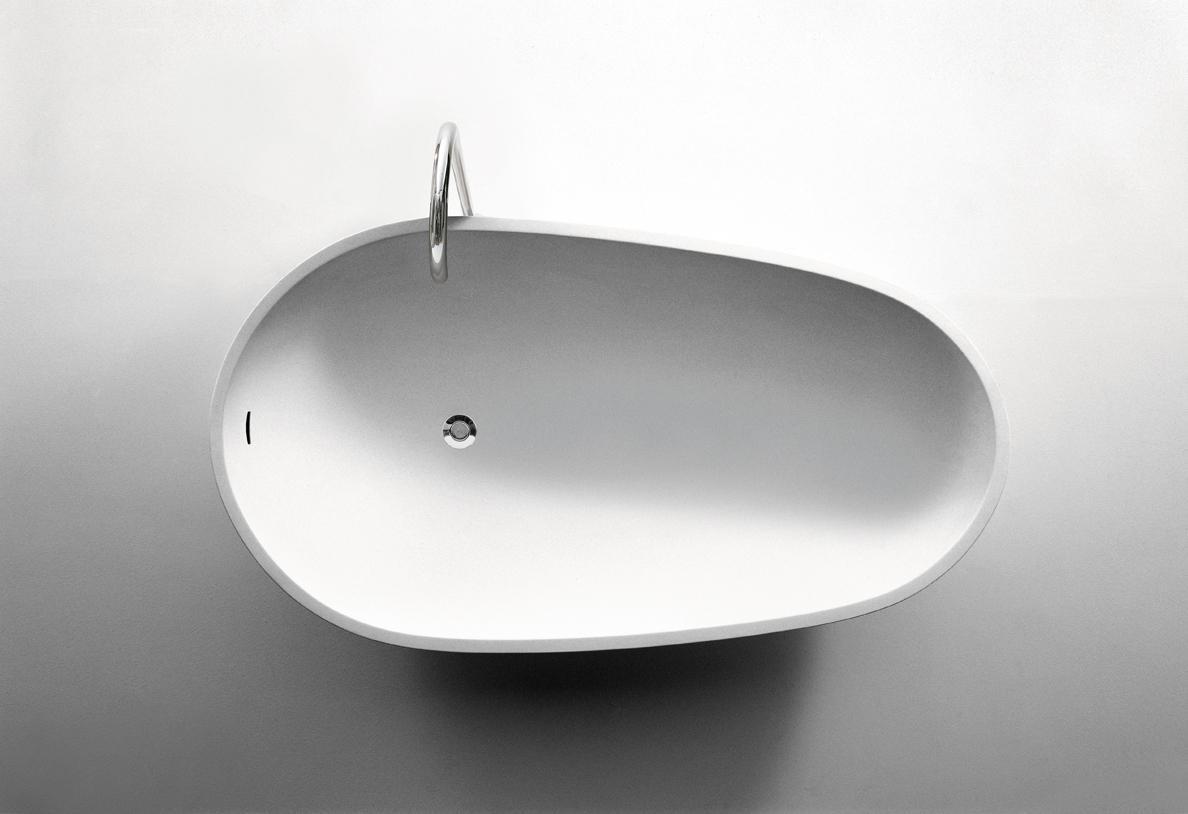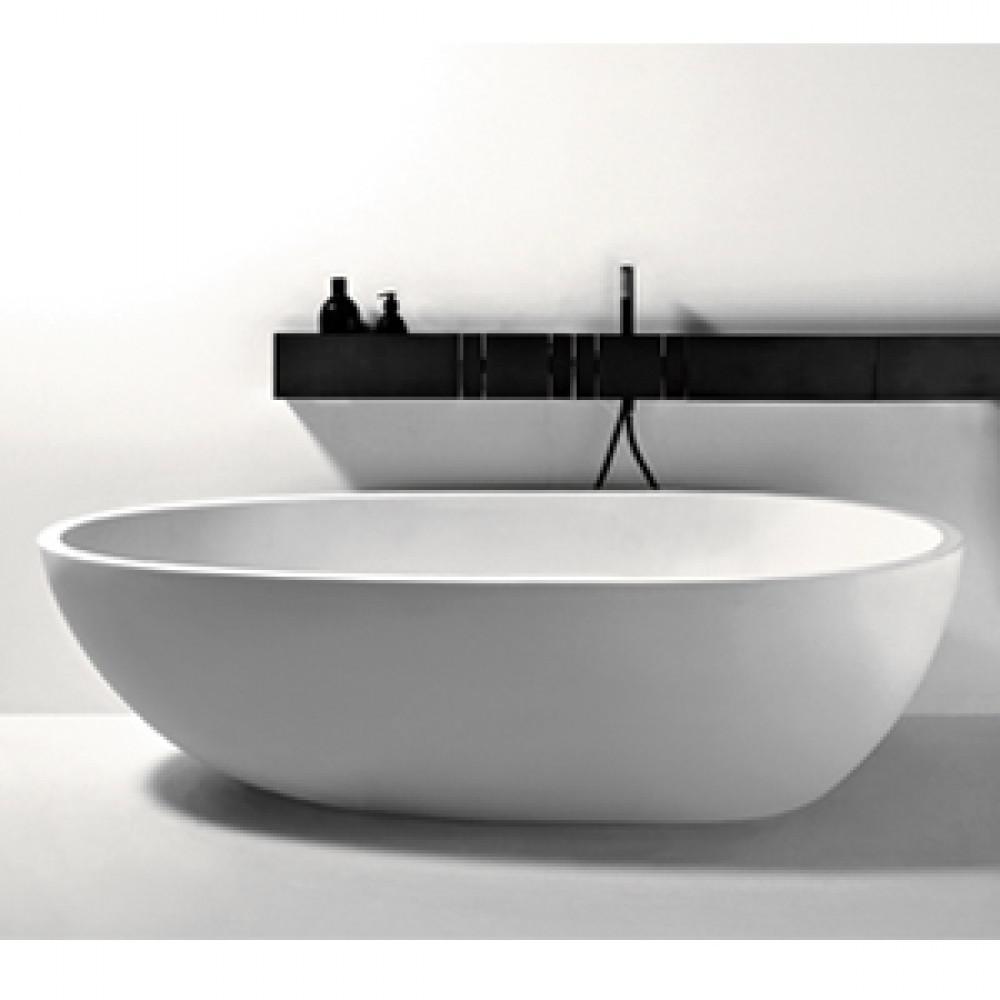The first image is the image on the left, the second image is the image on the right. Evaluate the accuracy of this statement regarding the images: "The left image features an aerial view of a rounded white uninstalled sink, and the right views shows the same sink shape on a counter under a black ledge with at least one bottle at the end of it.". Is it true? Answer yes or no. Yes. 